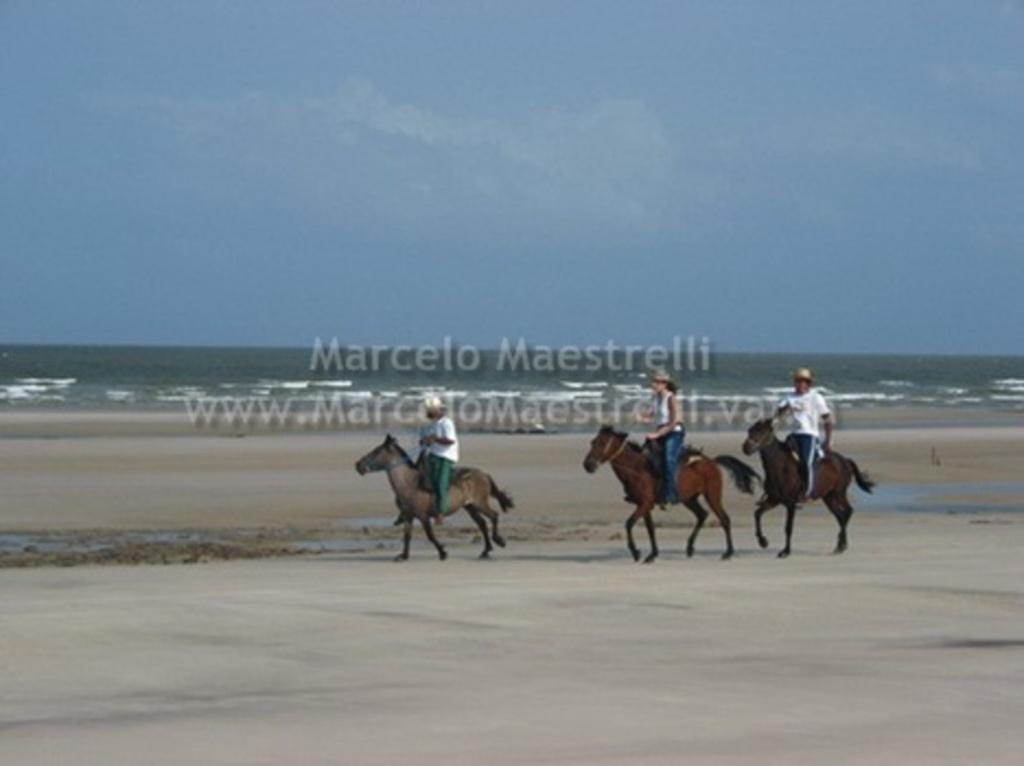How many people are in the image? There are three persons in the image. What are the persons doing in the image? The persons are riding horses. What can be seen in the background of the image? There is a sea visible in the background of the image. What is visible at the top of the image? The sky is visible at the top of the image. Where can you find a park in the image? There is no park present in the image. 